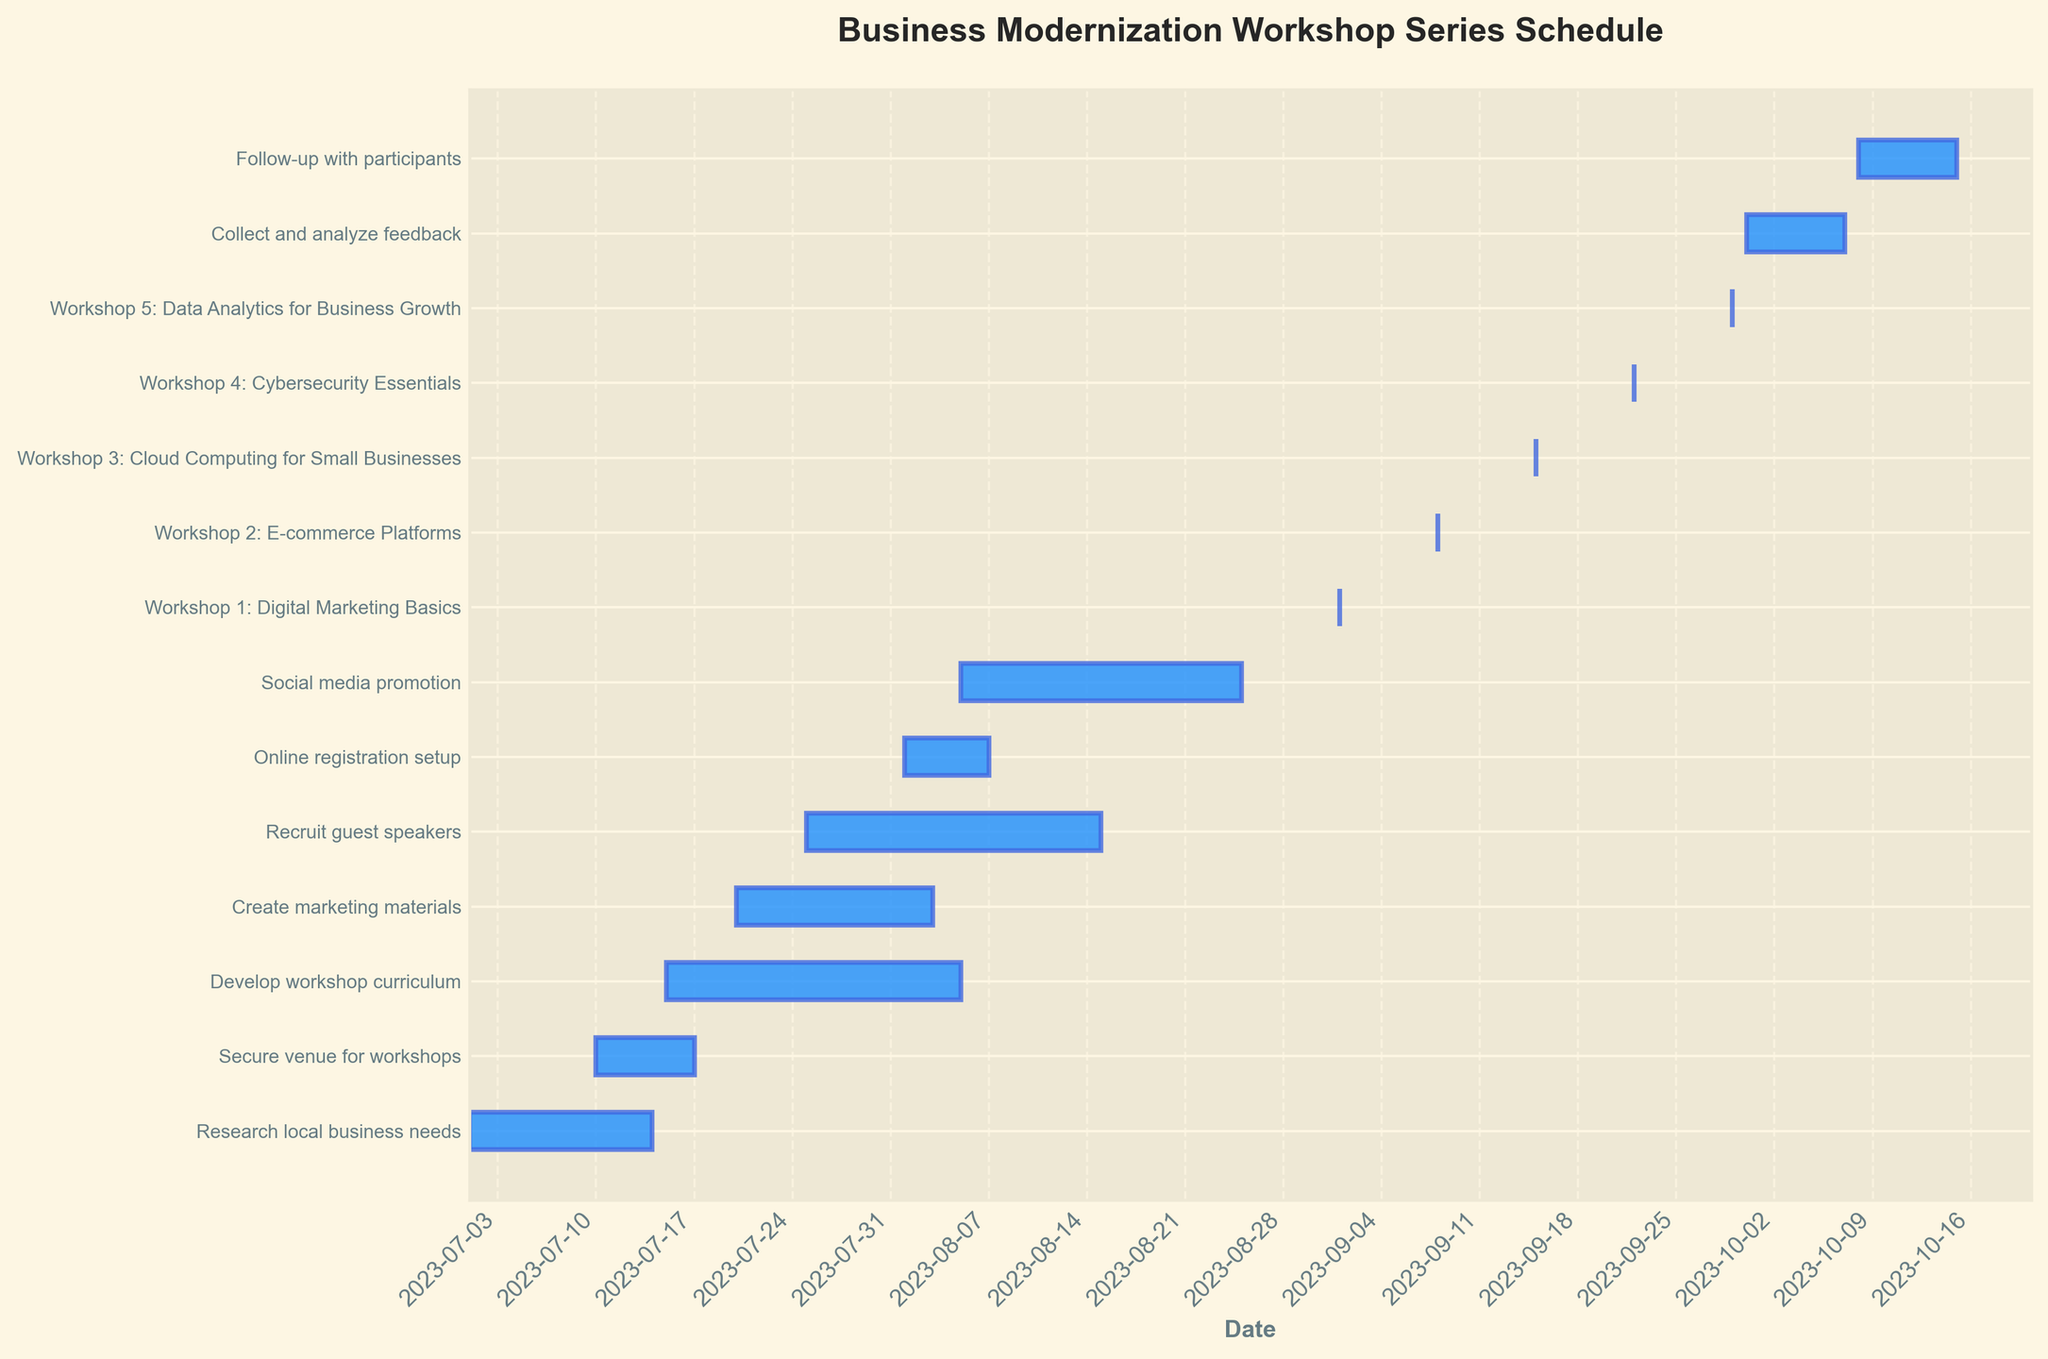What is the title of the figure? The title is typically placed at the top of the figure and is clearly marked to indicate the subject of the Gantt chart. In this case, it states "Business Modernization Workshop Series Schedule."
Answer: Business Modernization Workshop Series Schedule When does the task "Research local business needs" start and end? The bars corresponding to the tasks indicate the start and end dates. For "Research local business needs," the bar starts on 2023-07-01 and ends on 2023-07-14.
Answer: 2023-07-01 to 2023-07-14 Which task has the shortest duration? The task durations can be observed by the length of the bars. The shortest bar is for any of the workshops, each of which lasts 1 day. For example, "Workshop 1: Digital Marketing Basics" is on 2023-09-01, lasting 1 day.
Answer: Workshop 1: Digital Marketing Basics (1 day) How long is the duration of "Social media promotion"? The length of the bar for "Social media promotion" can be measured from its start to end. It starts on 2023-08-05 and ends on 2023-08-25, making the duration 21 days.
Answer: 21 days What is the y-axis label initially next to "Research local business needs"? The y-axis labels represent the different tasks in the schedule. The first label at the top corresponds to "Research local business needs."
Answer: Research local business needs Which task finishes first in August? Scan the Gantt chart to find the first bar that ends in August. "Secure venue for workshops" ends on 2023-07-17, so the first task finishing in August is "Create marketing materials" ending on 2023-08-03.
Answer: Create marketing materials When does the "Develop workshop curriculum" take place and how long does it last? Identify the bar for "Develop workshop curriculum." It begins on 2023-07-15 and ends on 2023-08-05 with a duration of (22 days).
Answer: 2023-07-15 to 2023-08-05, 22 days What overlapping tasks can be observed in July? Look at the bars extending in July to find overlapping tasks. "Secure venue for workshops" and "Research local business needs" overlap from 2023-07-10 to 2023-07-14. Also, "Create marketing materials" starts on 2023-07-20 before "Develop workshop curriculum" finishes.
Answer: Secure venue for workshops and Research local business needs (2023-07-10 to 2023-07-14) Which task spans both August and September? By following the bars extending over these months, "Social media promotion" can be seen to span from 2023-08-05 to 2023-08-25, thus covering both August and a part of September.
Answer: Social media promotion How many tasks end in September? Count the number of bars that end in September by observing the rightmost endpoint of each relevant task. There are six tasks ending in September - the five workshops plus the "Collect and analyze feedback."
Answer: Six tasks (5 workshops + 1 feedback) 